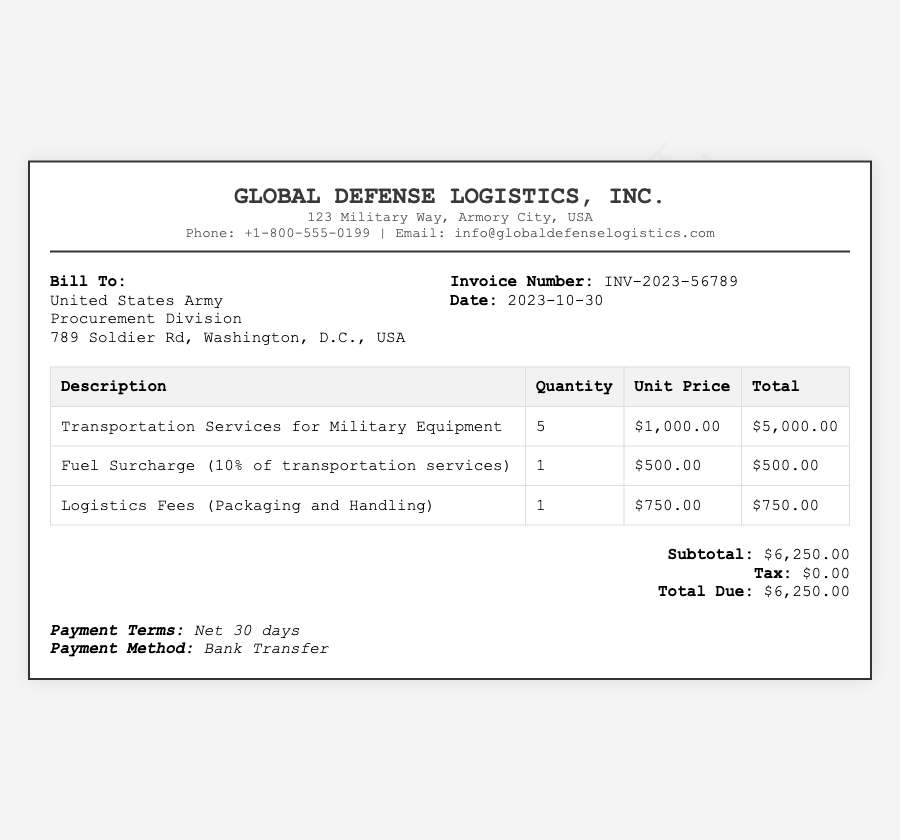What is the invoice number? The invoice number is specified in the document, labeled as "Invoice Number."
Answer: INV-2023-56789 What is the total due? The total due is the final amount listed in the summary section of the document.
Answer: $6,250.00 Who is the bill recipient? The document indicates that the bill is addressed to the "Bill To" section which identifies the recipient.
Answer: United States Army What is the date of the invoice? The date is explicitly mentioned in the invoice information section.
Answer: 2023-10-30 How many transportation services were provided? The quantity of transportation services is listed in the table under the "Quantity" column.
Answer: 5 What percentage is used for the fuel surcharge? The fuel surcharge percentage is stated in the description of that line item in the table.
Answer: 10% What payment terms are specified? The document mentions the payment terms in the payment terms section.
Answer: Net 30 days What is the unit price for logistics fees? The unit price for logistics fees is noted in the table under the relevant section.
Answer: $750.00 What city is Global Defense Logistics, Inc. located in? The city is mentioned in the contact information section of the header.
Answer: Armory City 